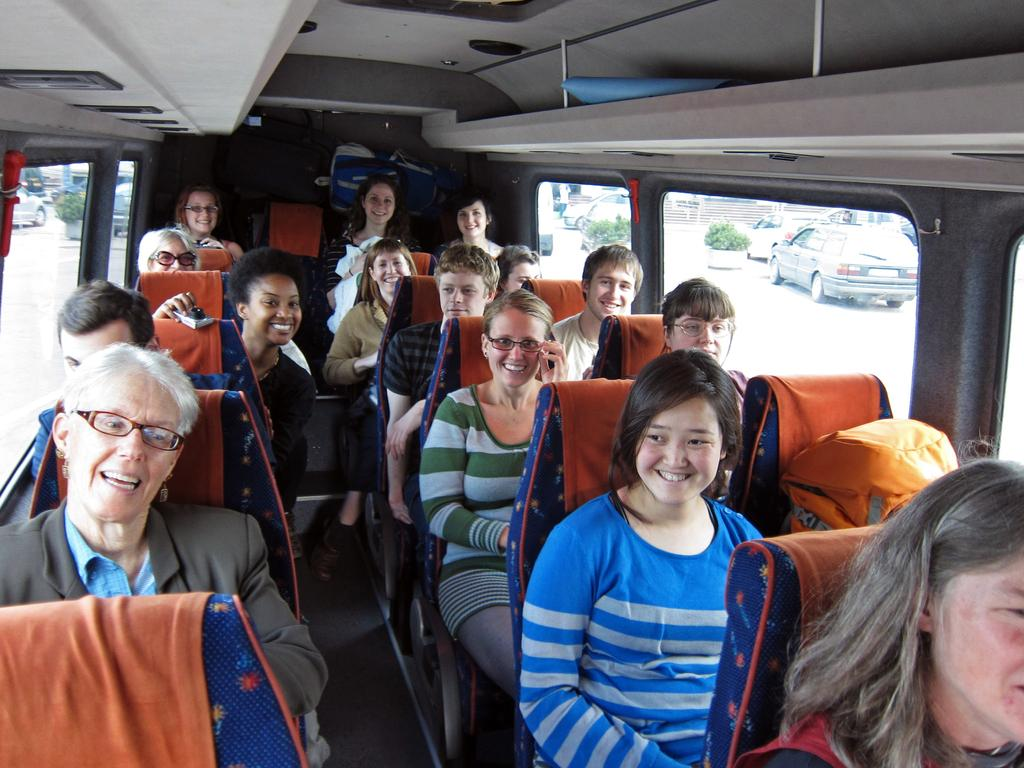What type of vehicle are the people sitting in? There are men and women sitting inside a bus. What can be seen through the windows of the bus? Cars and plants are visible on the road through the windows of the bus. What type of pain is the man in the bus experiencing? There is no indication in the image that any of the people are experiencing pain. 